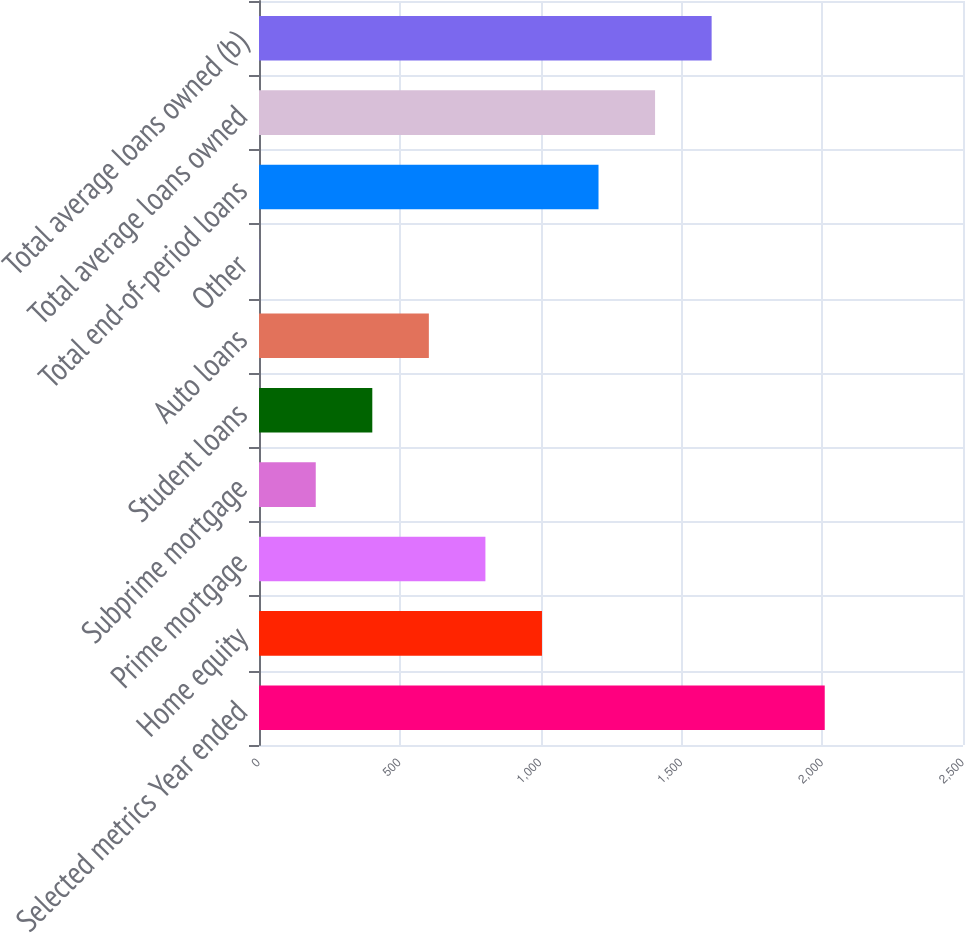<chart> <loc_0><loc_0><loc_500><loc_500><bar_chart><fcel>Selected metrics Year ended<fcel>Home equity<fcel>Prime mortgage<fcel>Subprime mortgage<fcel>Student loans<fcel>Auto loans<fcel>Other<fcel>Total end-of-period loans<fcel>Total average loans owned<fcel>Total average loans owned (b)<nl><fcel>2009<fcel>1004.85<fcel>804.02<fcel>201.53<fcel>402.36<fcel>603.19<fcel>0.7<fcel>1205.68<fcel>1406.51<fcel>1607.34<nl></chart> 